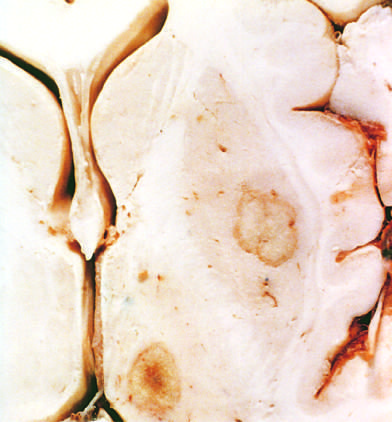where are abscesses present?
Answer the question using a single word or phrase. In the putamen and thalamus 